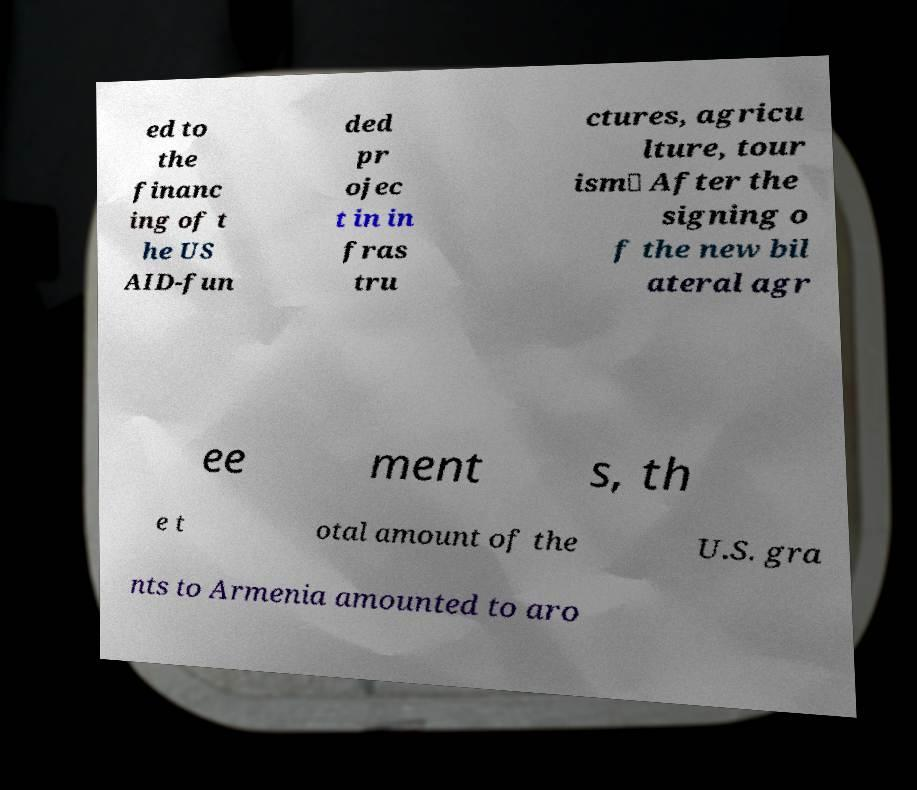What messages or text are displayed in this image? I need them in a readable, typed format. ed to the financ ing of t he US AID-fun ded pr ojec t in in fras tru ctures, agricu lture, tour ism․ After the signing o f the new bil ateral agr ee ment s, th e t otal amount of the U.S. gra nts to Armenia amounted to aro 